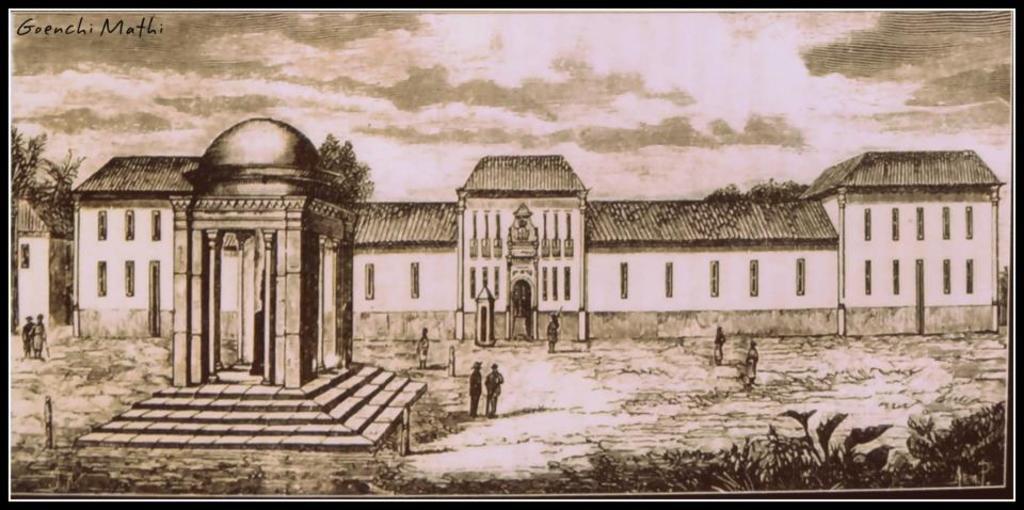Can you describe this image briefly? In this image I can see the art of few people and the buildings. To the right I can see the plants. In the background I can see the trees, clouds and the sky. 